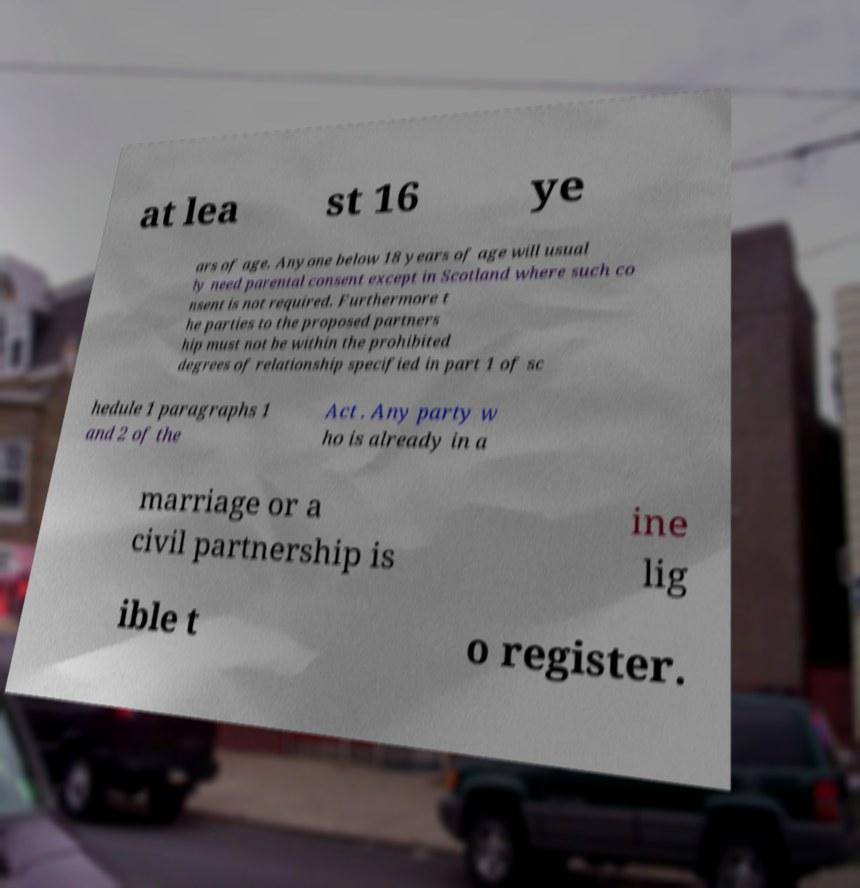Please identify and transcribe the text found in this image. at lea st 16 ye ars of age. Anyone below 18 years of age will usual ly need parental consent except in Scotland where such co nsent is not required. Furthermore t he parties to the proposed partners hip must not be within the prohibited degrees of relationship specified in part 1 of sc hedule 1 paragraphs 1 and 2 of the Act . Any party w ho is already in a marriage or a civil partnership is ine lig ible t o register. 